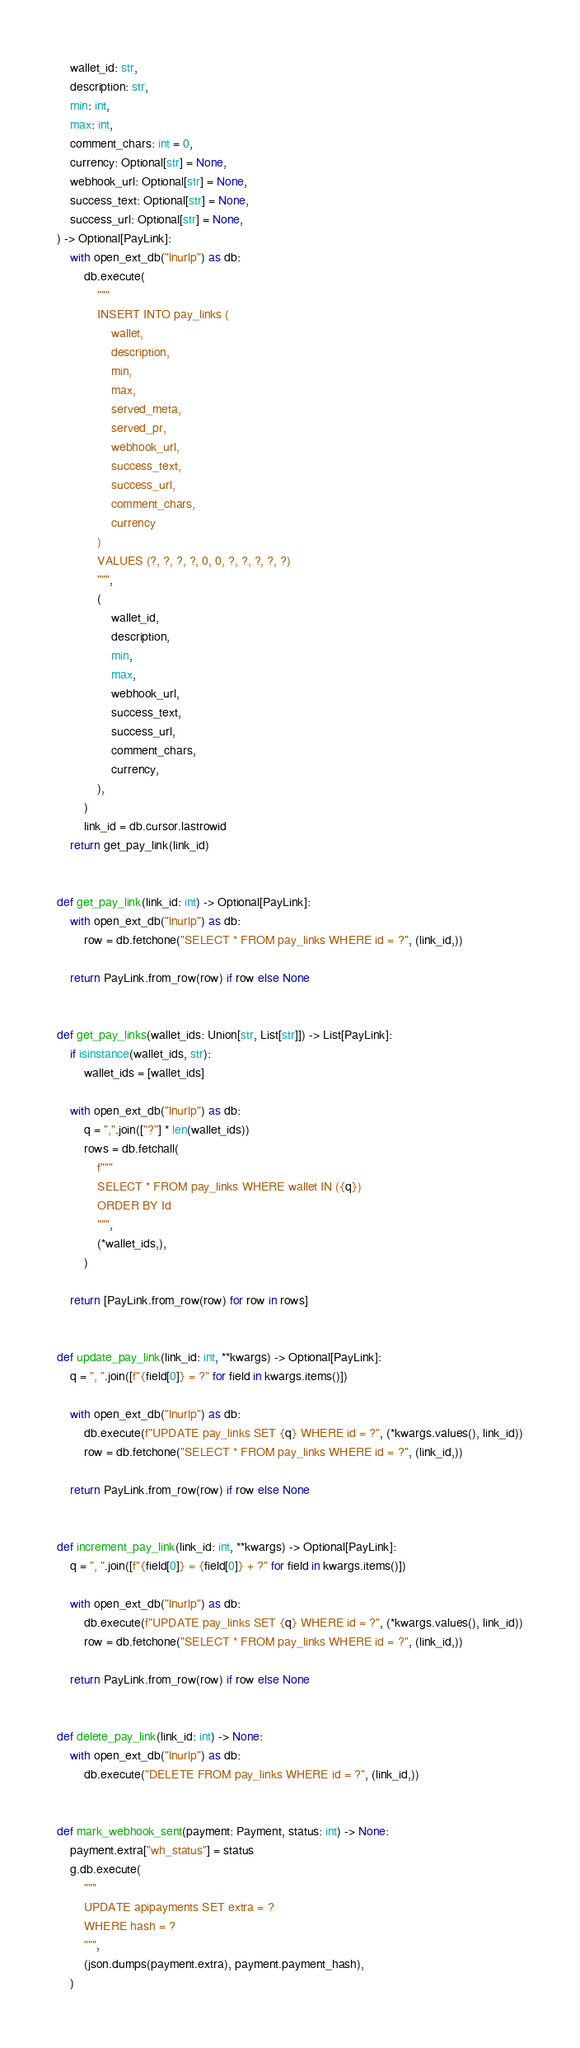Convert code to text. <code><loc_0><loc_0><loc_500><loc_500><_Python_>    wallet_id: str,
    description: str,
    min: int,
    max: int,
    comment_chars: int = 0,
    currency: Optional[str] = None,
    webhook_url: Optional[str] = None,
    success_text: Optional[str] = None,
    success_url: Optional[str] = None,
) -> Optional[PayLink]:
    with open_ext_db("lnurlp") as db:
        db.execute(
            """
            INSERT INTO pay_links (
                wallet,
                description,
                min,
                max,
                served_meta,
                served_pr,
                webhook_url,
                success_text,
                success_url,
                comment_chars,
                currency
            )
            VALUES (?, ?, ?, ?, 0, 0, ?, ?, ?, ?, ?)
            """,
            (
                wallet_id,
                description,
                min,
                max,
                webhook_url,
                success_text,
                success_url,
                comment_chars,
                currency,
            ),
        )
        link_id = db.cursor.lastrowid
    return get_pay_link(link_id)


def get_pay_link(link_id: int) -> Optional[PayLink]:
    with open_ext_db("lnurlp") as db:
        row = db.fetchone("SELECT * FROM pay_links WHERE id = ?", (link_id,))

    return PayLink.from_row(row) if row else None


def get_pay_links(wallet_ids: Union[str, List[str]]) -> List[PayLink]:
    if isinstance(wallet_ids, str):
        wallet_ids = [wallet_ids]

    with open_ext_db("lnurlp") as db:
        q = ",".join(["?"] * len(wallet_ids))
        rows = db.fetchall(
            f"""
            SELECT * FROM pay_links WHERE wallet IN ({q})
            ORDER BY Id
            """,
            (*wallet_ids,),
        )

    return [PayLink.from_row(row) for row in rows]


def update_pay_link(link_id: int, **kwargs) -> Optional[PayLink]:
    q = ", ".join([f"{field[0]} = ?" for field in kwargs.items()])

    with open_ext_db("lnurlp") as db:
        db.execute(f"UPDATE pay_links SET {q} WHERE id = ?", (*kwargs.values(), link_id))
        row = db.fetchone("SELECT * FROM pay_links WHERE id = ?", (link_id,))

    return PayLink.from_row(row) if row else None


def increment_pay_link(link_id: int, **kwargs) -> Optional[PayLink]:
    q = ", ".join([f"{field[0]} = {field[0]} + ?" for field in kwargs.items()])

    with open_ext_db("lnurlp") as db:
        db.execute(f"UPDATE pay_links SET {q} WHERE id = ?", (*kwargs.values(), link_id))
        row = db.fetchone("SELECT * FROM pay_links WHERE id = ?", (link_id,))

    return PayLink.from_row(row) if row else None


def delete_pay_link(link_id: int) -> None:
    with open_ext_db("lnurlp") as db:
        db.execute("DELETE FROM pay_links WHERE id = ?", (link_id,))


def mark_webhook_sent(payment: Payment, status: int) -> None:
    payment.extra["wh_status"] = status
    g.db.execute(
        """
        UPDATE apipayments SET extra = ?
        WHERE hash = ?
        """,
        (json.dumps(payment.extra), payment.payment_hash),
    )
</code> 